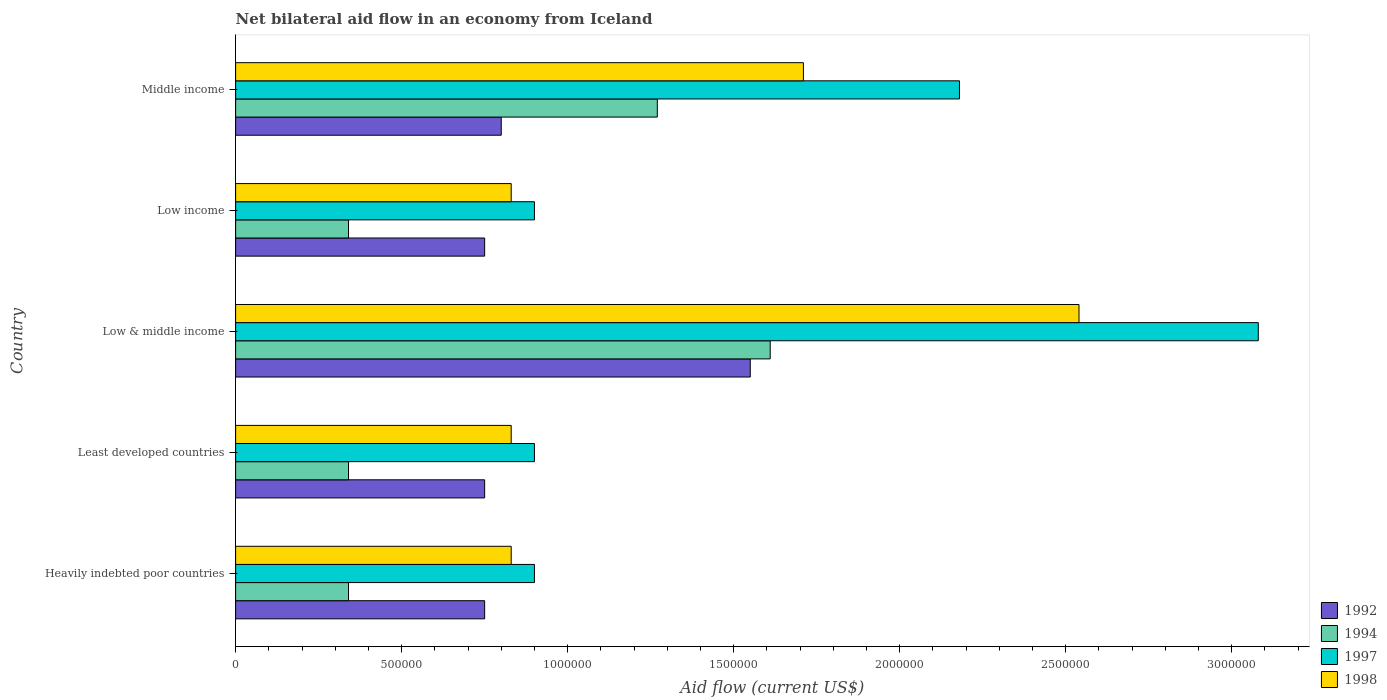How many bars are there on the 2nd tick from the bottom?
Your answer should be compact. 4. What is the label of the 5th group of bars from the top?
Ensure brevity in your answer.  Heavily indebted poor countries. In how many cases, is the number of bars for a given country not equal to the number of legend labels?
Keep it short and to the point. 0. What is the net bilateral aid flow in 1994 in Middle income?
Offer a terse response. 1.27e+06. Across all countries, what is the maximum net bilateral aid flow in 1998?
Offer a very short reply. 2.54e+06. In which country was the net bilateral aid flow in 1994 maximum?
Provide a succinct answer. Low & middle income. In which country was the net bilateral aid flow in 1992 minimum?
Your answer should be very brief. Heavily indebted poor countries. What is the total net bilateral aid flow in 1994 in the graph?
Offer a very short reply. 3.90e+06. What is the difference between the net bilateral aid flow in 1997 in Heavily indebted poor countries and the net bilateral aid flow in 1998 in Middle income?
Make the answer very short. -8.10e+05. What is the average net bilateral aid flow in 1997 per country?
Your answer should be compact. 1.59e+06. What is the difference between the net bilateral aid flow in 1998 and net bilateral aid flow in 1992 in Middle income?
Your answer should be very brief. 9.10e+05. In how many countries, is the net bilateral aid flow in 1992 greater than 2100000 US$?
Keep it short and to the point. 0. What is the ratio of the net bilateral aid flow in 1997 in Low & middle income to that in Low income?
Your response must be concise. 3.42. Is the net bilateral aid flow in 1997 in Least developed countries less than that in Middle income?
Ensure brevity in your answer.  Yes. Is the difference between the net bilateral aid flow in 1998 in Heavily indebted poor countries and Least developed countries greater than the difference between the net bilateral aid flow in 1992 in Heavily indebted poor countries and Least developed countries?
Offer a terse response. No. What is the difference between the highest and the second highest net bilateral aid flow in 1994?
Make the answer very short. 3.40e+05. What is the difference between the highest and the lowest net bilateral aid flow in 1997?
Give a very brief answer. 2.18e+06. Is the sum of the net bilateral aid flow in 1998 in Heavily indebted poor countries and Low & middle income greater than the maximum net bilateral aid flow in 1992 across all countries?
Keep it short and to the point. Yes. Is it the case that in every country, the sum of the net bilateral aid flow in 1992 and net bilateral aid flow in 1998 is greater than the sum of net bilateral aid flow in 1994 and net bilateral aid flow in 1997?
Your response must be concise. Yes. What does the 4th bar from the top in Least developed countries represents?
Give a very brief answer. 1992. What does the 2nd bar from the bottom in Low & middle income represents?
Give a very brief answer. 1994. Is it the case that in every country, the sum of the net bilateral aid flow in 1994 and net bilateral aid flow in 1998 is greater than the net bilateral aid flow in 1992?
Provide a short and direct response. Yes. How many bars are there?
Provide a succinct answer. 20. How many countries are there in the graph?
Make the answer very short. 5. Are the values on the major ticks of X-axis written in scientific E-notation?
Offer a terse response. No. Where does the legend appear in the graph?
Ensure brevity in your answer.  Bottom right. What is the title of the graph?
Make the answer very short. Net bilateral aid flow in an economy from Iceland. Does "1960" appear as one of the legend labels in the graph?
Offer a terse response. No. What is the label or title of the X-axis?
Provide a succinct answer. Aid flow (current US$). What is the label or title of the Y-axis?
Your answer should be very brief. Country. What is the Aid flow (current US$) in 1992 in Heavily indebted poor countries?
Make the answer very short. 7.50e+05. What is the Aid flow (current US$) of 1998 in Heavily indebted poor countries?
Your answer should be compact. 8.30e+05. What is the Aid flow (current US$) of 1992 in Least developed countries?
Give a very brief answer. 7.50e+05. What is the Aid flow (current US$) in 1994 in Least developed countries?
Your response must be concise. 3.40e+05. What is the Aid flow (current US$) of 1998 in Least developed countries?
Offer a very short reply. 8.30e+05. What is the Aid flow (current US$) in 1992 in Low & middle income?
Offer a terse response. 1.55e+06. What is the Aid flow (current US$) of 1994 in Low & middle income?
Provide a succinct answer. 1.61e+06. What is the Aid flow (current US$) of 1997 in Low & middle income?
Ensure brevity in your answer.  3.08e+06. What is the Aid flow (current US$) of 1998 in Low & middle income?
Offer a terse response. 2.54e+06. What is the Aid flow (current US$) in 1992 in Low income?
Provide a succinct answer. 7.50e+05. What is the Aid flow (current US$) in 1998 in Low income?
Make the answer very short. 8.30e+05. What is the Aid flow (current US$) of 1992 in Middle income?
Your answer should be compact. 8.00e+05. What is the Aid flow (current US$) of 1994 in Middle income?
Make the answer very short. 1.27e+06. What is the Aid flow (current US$) in 1997 in Middle income?
Provide a short and direct response. 2.18e+06. What is the Aid flow (current US$) of 1998 in Middle income?
Provide a succinct answer. 1.71e+06. Across all countries, what is the maximum Aid flow (current US$) in 1992?
Provide a succinct answer. 1.55e+06. Across all countries, what is the maximum Aid flow (current US$) in 1994?
Your response must be concise. 1.61e+06. Across all countries, what is the maximum Aid flow (current US$) in 1997?
Ensure brevity in your answer.  3.08e+06. Across all countries, what is the maximum Aid flow (current US$) of 1998?
Provide a succinct answer. 2.54e+06. Across all countries, what is the minimum Aid flow (current US$) in 1992?
Your answer should be compact. 7.50e+05. Across all countries, what is the minimum Aid flow (current US$) in 1994?
Give a very brief answer. 3.40e+05. Across all countries, what is the minimum Aid flow (current US$) in 1997?
Give a very brief answer. 9.00e+05. Across all countries, what is the minimum Aid flow (current US$) of 1998?
Ensure brevity in your answer.  8.30e+05. What is the total Aid flow (current US$) of 1992 in the graph?
Offer a very short reply. 4.60e+06. What is the total Aid flow (current US$) of 1994 in the graph?
Your answer should be very brief. 3.90e+06. What is the total Aid flow (current US$) in 1997 in the graph?
Your answer should be compact. 7.96e+06. What is the total Aid flow (current US$) in 1998 in the graph?
Your answer should be compact. 6.74e+06. What is the difference between the Aid flow (current US$) of 1992 in Heavily indebted poor countries and that in Least developed countries?
Provide a succinct answer. 0. What is the difference between the Aid flow (current US$) of 1994 in Heavily indebted poor countries and that in Least developed countries?
Your response must be concise. 0. What is the difference between the Aid flow (current US$) of 1992 in Heavily indebted poor countries and that in Low & middle income?
Provide a succinct answer. -8.00e+05. What is the difference between the Aid flow (current US$) in 1994 in Heavily indebted poor countries and that in Low & middle income?
Offer a very short reply. -1.27e+06. What is the difference between the Aid flow (current US$) in 1997 in Heavily indebted poor countries and that in Low & middle income?
Your response must be concise. -2.18e+06. What is the difference between the Aid flow (current US$) in 1998 in Heavily indebted poor countries and that in Low & middle income?
Your answer should be very brief. -1.71e+06. What is the difference between the Aid flow (current US$) in 1992 in Heavily indebted poor countries and that in Low income?
Your answer should be very brief. 0. What is the difference between the Aid flow (current US$) in 1997 in Heavily indebted poor countries and that in Low income?
Your answer should be compact. 0. What is the difference between the Aid flow (current US$) of 1998 in Heavily indebted poor countries and that in Low income?
Provide a short and direct response. 0. What is the difference between the Aid flow (current US$) in 1994 in Heavily indebted poor countries and that in Middle income?
Offer a terse response. -9.30e+05. What is the difference between the Aid flow (current US$) in 1997 in Heavily indebted poor countries and that in Middle income?
Offer a terse response. -1.28e+06. What is the difference between the Aid flow (current US$) of 1998 in Heavily indebted poor countries and that in Middle income?
Offer a very short reply. -8.80e+05. What is the difference between the Aid flow (current US$) in 1992 in Least developed countries and that in Low & middle income?
Provide a short and direct response. -8.00e+05. What is the difference between the Aid flow (current US$) in 1994 in Least developed countries and that in Low & middle income?
Offer a very short reply. -1.27e+06. What is the difference between the Aid flow (current US$) of 1997 in Least developed countries and that in Low & middle income?
Your answer should be very brief. -2.18e+06. What is the difference between the Aid flow (current US$) of 1998 in Least developed countries and that in Low & middle income?
Ensure brevity in your answer.  -1.71e+06. What is the difference between the Aid flow (current US$) in 1998 in Least developed countries and that in Low income?
Ensure brevity in your answer.  0. What is the difference between the Aid flow (current US$) of 1992 in Least developed countries and that in Middle income?
Offer a terse response. -5.00e+04. What is the difference between the Aid flow (current US$) in 1994 in Least developed countries and that in Middle income?
Provide a short and direct response. -9.30e+05. What is the difference between the Aid flow (current US$) of 1997 in Least developed countries and that in Middle income?
Keep it short and to the point. -1.28e+06. What is the difference between the Aid flow (current US$) in 1998 in Least developed countries and that in Middle income?
Your answer should be very brief. -8.80e+05. What is the difference between the Aid flow (current US$) of 1994 in Low & middle income and that in Low income?
Provide a short and direct response. 1.27e+06. What is the difference between the Aid flow (current US$) in 1997 in Low & middle income and that in Low income?
Give a very brief answer. 2.18e+06. What is the difference between the Aid flow (current US$) of 1998 in Low & middle income and that in Low income?
Provide a short and direct response. 1.71e+06. What is the difference between the Aid flow (current US$) in 1992 in Low & middle income and that in Middle income?
Offer a very short reply. 7.50e+05. What is the difference between the Aid flow (current US$) in 1994 in Low & middle income and that in Middle income?
Make the answer very short. 3.40e+05. What is the difference between the Aid flow (current US$) of 1998 in Low & middle income and that in Middle income?
Your answer should be very brief. 8.30e+05. What is the difference between the Aid flow (current US$) in 1994 in Low income and that in Middle income?
Provide a short and direct response. -9.30e+05. What is the difference between the Aid flow (current US$) in 1997 in Low income and that in Middle income?
Give a very brief answer. -1.28e+06. What is the difference between the Aid flow (current US$) of 1998 in Low income and that in Middle income?
Your response must be concise. -8.80e+05. What is the difference between the Aid flow (current US$) in 1994 in Heavily indebted poor countries and the Aid flow (current US$) in 1997 in Least developed countries?
Provide a succinct answer. -5.60e+05. What is the difference between the Aid flow (current US$) in 1994 in Heavily indebted poor countries and the Aid flow (current US$) in 1998 in Least developed countries?
Make the answer very short. -4.90e+05. What is the difference between the Aid flow (current US$) of 1997 in Heavily indebted poor countries and the Aid flow (current US$) of 1998 in Least developed countries?
Your response must be concise. 7.00e+04. What is the difference between the Aid flow (current US$) in 1992 in Heavily indebted poor countries and the Aid flow (current US$) in 1994 in Low & middle income?
Provide a short and direct response. -8.60e+05. What is the difference between the Aid flow (current US$) of 1992 in Heavily indebted poor countries and the Aid flow (current US$) of 1997 in Low & middle income?
Your answer should be very brief. -2.33e+06. What is the difference between the Aid flow (current US$) of 1992 in Heavily indebted poor countries and the Aid flow (current US$) of 1998 in Low & middle income?
Offer a very short reply. -1.79e+06. What is the difference between the Aid flow (current US$) of 1994 in Heavily indebted poor countries and the Aid flow (current US$) of 1997 in Low & middle income?
Ensure brevity in your answer.  -2.74e+06. What is the difference between the Aid flow (current US$) of 1994 in Heavily indebted poor countries and the Aid flow (current US$) of 1998 in Low & middle income?
Provide a succinct answer. -2.20e+06. What is the difference between the Aid flow (current US$) in 1997 in Heavily indebted poor countries and the Aid flow (current US$) in 1998 in Low & middle income?
Your answer should be very brief. -1.64e+06. What is the difference between the Aid flow (current US$) of 1992 in Heavily indebted poor countries and the Aid flow (current US$) of 1997 in Low income?
Keep it short and to the point. -1.50e+05. What is the difference between the Aid flow (current US$) in 1992 in Heavily indebted poor countries and the Aid flow (current US$) in 1998 in Low income?
Provide a short and direct response. -8.00e+04. What is the difference between the Aid flow (current US$) in 1994 in Heavily indebted poor countries and the Aid flow (current US$) in 1997 in Low income?
Provide a short and direct response. -5.60e+05. What is the difference between the Aid flow (current US$) in 1994 in Heavily indebted poor countries and the Aid flow (current US$) in 1998 in Low income?
Make the answer very short. -4.90e+05. What is the difference between the Aid flow (current US$) of 1992 in Heavily indebted poor countries and the Aid flow (current US$) of 1994 in Middle income?
Give a very brief answer. -5.20e+05. What is the difference between the Aid flow (current US$) in 1992 in Heavily indebted poor countries and the Aid flow (current US$) in 1997 in Middle income?
Your answer should be compact. -1.43e+06. What is the difference between the Aid flow (current US$) in 1992 in Heavily indebted poor countries and the Aid flow (current US$) in 1998 in Middle income?
Your answer should be very brief. -9.60e+05. What is the difference between the Aid flow (current US$) of 1994 in Heavily indebted poor countries and the Aid flow (current US$) of 1997 in Middle income?
Your response must be concise. -1.84e+06. What is the difference between the Aid flow (current US$) of 1994 in Heavily indebted poor countries and the Aid flow (current US$) of 1998 in Middle income?
Your answer should be very brief. -1.37e+06. What is the difference between the Aid flow (current US$) of 1997 in Heavily indebted poor countries and the Aid flow (current US$) of 1998 in Middle income?
Your answer should be very brief. -8.10e+05. What is the difference between the Aid flow (current US$) of 1992 in Least developed countries and the Aid flow (current US$) of 1994 in Low & middle income?
Provide a short and direct response. -8.60e+05. What is the difference between the Aid flow (current US$) of 1992 in Least developed countries and the Aid flow (current US$) of 1997 in Low & middle income?
Make the answer very short. -2.33e+06. What is the difference between the Aid flow (current US$) in 1992 in Least developed countries and the Aid flow (current US$) in 1998 in Low & middle income?
Make the answer very short. -1.79e+06. What is the difference between the Aid flow (current US$) in 1994 in Least developed countries and the Aid flow (current US$) in 1997 in Low & middle income?
Provide a short and direct response. -2.74e+06. What is the difference between the Aid flow (current US$) in 1994 in Least developed countries and the Aid flow (current US$) in 1998 in Low & middle income?
Ensure brevity in your answer.  -2.20e+06. What is the difference between the Aid flow (current US$) in 1997 in Least developed countries and the Aid flow (current US$) in 1998 in Low & middle income?
Make the answer very short. -1.64e+06. What is the difference between the Aid flow (current US$) of 1992 in Least developed countries and the Aid flow (current US$) of 1997 in Low income?
Your response must be concise. -1.50e+05. What is the difference between the Aid flow (current US$) of 1992 in Least developed countries and the Aid flow (current US$) of 1998 in Low income?
Ensure brevity in your answer.  -8.00e+04. What is the difference between the Aid flow (current US$) in 1994 in Least developed countries and the Aid flow (current US$) in 1997 in Low income?
Your answer should be very brief. -5.60e+05. What is the difference between the Aid flow (current US$) of 1994 in Least developed countries and the Aid flow (current US$) of 1998 in Low income?
Ensure brevity in your answer.  -4.90e+05. What is the difference between the Aid flow (current US$) of 1992 in Least developed countries and the Aid flow (current US$) of 1994 in Middle income?
Ensure brevity in your answer.  -5.20e+05. What is the difference between the Aid flow (current US$) in 1992 in Least developed countries and the Aid flow (current US$) in 1997 in Middle income?
Your response must be concise. -1.43e+06. What is the difference between the Aid flow (current US$) of 1992 in Least developed countries and the Aid flow (current US$) of 1998 in Middle income?
Provide a short and direct response. -9.60e+05. What is the difference between the Aid flow (current US$) of 1994 in Least developed countries and the Aid flow (current US$) of 1997 in Middle income?
Give a very brief answer. -1.84e+06. What is the difference between the Aid flow (current US$) of 1994 in Least developed countries and the Aid flow (current US$) of 1998 in Middle income?
Your answer should be very brief. -1.37e+06. What is the difference between the Aid flow (current US$) of 1997 in Least developed countries and the Aid flow (current US$) of 1998 in Middle income?
Your answer should be very brief. -8.10e+05. What is the difference between the Aid flow (current US$) in 1992 in Low & middle income and the Aid flow (current US$) in 1994 in Low income?
Keep it short and to the point. 1.21e+06. What is the difference between the Aid flow (current US$) in 1992 in Low & middle income and the Aid flow (current US$) in 1997 in Low income?
Keep it short and to the point. 6.50e+05. What is the difference between the Aid flow (current US$) in 1992 in Low & middle income and the Aid flow (current US$) in 1998 in Low income?
Make the answer very short. 7.20e+05. What is the difference between the Aid flow (current US$) in 1994 in Low & middle income and the Aid flow (current US$) in 1997 in Low income?
Your response must be concise. 7.10e+05. What is the difference between the Aid flow (current US$) in 1994 in Low & middle income and the Aid flow (current US$) in 1998 in Low income?
Ensure brevity in your answer.  7.80e+05. What is the difference between the Aid flow (current US$) in 1997 in Low & middle income and the Aid flow (current US$) in 1998 in Low income?
Your response must be concise. 2.25e+06. What is the difference between the Aid flow (current US$) in 1992 in Low & middle income and the Aid flow (current US$) in 1997 in Middle income?
Your answer should be compact. -6.30e+05. What is the difference between the Aid flow (current US$) in 1994 in Low & middle income and the Aid flow (current US$) in 1997 in Middle income?
Your answer should be very brief. -5.70e+05. What is the difference between the Aid flow (current US$) of 1997 in Low & middle income and the Aid flow (current US$) of 1998 in Middle income?
Provide a succinct answer. 1.37e+06. What is the difference between the Aid flow (current US$) in 1992 in Low income and the Aid flow (current US$) in 1994 in Middle income?
Your answer should be very brief. -5.20e+05. What is the difference between the Aid flow (current US$) of 1992 in Low income and the Aid flow (current US$) of 1997 in Middle income?
Ensure brevity in your answer.  -1.43e+06. What is the difference between the Aid flow (current US$) in 1992 in Low income and the Aid flow (current US$) in 1998 in Middle income?
Offer a very short reply. -9.60e+05. What is the difference between the Aid flow (current US$) of 1994 in Low income and the Aid flow (current US$) of 1997 in Middle income?
Offer a very short reply. -1.84e+06. What is the difference between the Aid flow (current US$) in 1994 in Low income and the Aid flow (current US$) in 1998 in Middle income?
Give a very brief answer. -1.37e+06. What is the difference between the Aid flow (current US$) in 1997 in Low income and the Aid flow (current US$) in 1998 in Middle income?
Offer a terse response. -8.10e+05. What is the average Aid flow (current US$) of 1992 per country?
Your response must be concise. 9.20e+05. What is the average Aid flow (current US$) in 1994 per country?
Your response must be concise. 7.80e+05. What is the average Aid flow (current US$) in 1997 per country?
Give a very brief answer. 1.59e+06. What is the average Aid flow (current US$) of 1998 per country?
Offer a very short reply. 1.35e+06. What is the difference between the Aid flow (current US$) of 1992 and Aid flow (current US$) of 1997 in Heavily indebted poor countries?
Your response must be concise. -1.50e+05. What is the difference between the Aid flow (current US$) of 1992 and Aid flow (current US$) of 1998 in Heavily indebted poor countries?
Offer a terse response. -8.00e+04. What is the difference between the Aid flow (current US$) in 1994 and Aid flow (current US$) in 1997 in Heavily indebted poor countries?
Your answer should be very brief. -5.60e+05. What is the difference between the Aid flow (current US$) in 1994 and Aid flow (current US$) in 1998 in Heavily indebted poor countries?
Provide a short and direct response. -4.90e+05. What is the difference between the Aid flow (current US$) in 1992 and Aid flow (current US$) in 1997 in Least developed countries?
Your response must be concise. -1.50e+05. What is the difference between the Aid flow (current US$) of 1994 and Aid flow (current US$) of 1997 in Least developed countries?
Provide a short and direct response. -5.60e+05. What is the difference between the Aid flow (current US$) of 1994 and Aid flow (current US$) of 1998 in Least developed countries?
Your response must be concise. -4.90e+05. What is the difference between the Aid flow (current US$) of 1992 and Aid flow (current US$) of 1994 in Low & middle income?
Offer a terse response. -6.00e+04. What is the difference between the Aid flow (current US$) of 1992 and Aid flow (current US$) of 1997 in Low & middle income?
Keep it short and to the point. -1.53e+06. What is the difference between the Aid flow (current US$) in 1992 and Aid flow (current US$) in 1998 in Low & middle income?
Offer a terse response. -9.90e+05. What is the difference between the Aid flow (current US$) in 1994 and Aid flow (current US$) in 1997 in Low & middle income?
Offer a very short reply. -1.47e+06. What is the difference between the Aid flow (current US$) of 1994 and Aid flow (current US$) of 1998 in Low & middle income?
Give a very brief answer. -9.30e+05. What is the difference between the Aid flow (current US$) of 1997 and Aid flow (current US$) of 1998 in Low & middle income?
Ensure brevity in your answer.  5.40e+05. What is the difference between the Aid flow (current US$) in 1994 and Aid flow (current US$) in 1997 in Low income?
Make the answer very short. -5.60e+05. What is the difference between the Aid flow (current US$) in 1994 and Aid flow (current US$) in 1998 in Low income?
Give a very brief answer. -4.90e+05. What is the difference between the Aid flow (current US$) of 1997 and Aid flow (current US$) of 1998 in Low income?
Provide a succinct answer. 7.00e+04. What is the difference between the Aid flow (current US$) of 1992 and Aid flow (current US$) of 1994 in Middle income?
Keep it short and to the point. -4.70e+05. What is the difference between the Aid flow (current US$) in 1992 and Aid flow (current US$) in 1997 in Middle income?
Offer a terse response. -1.38e+06. What is the difference between the Aid flow (current US$) in 1992 and Aid flow (current US$) in 1998 in Middle income?
Your response must be concise. -9.10e+05. What is the difference between the Aid flow (current US$) of 1994 and Aid flow (current US$) of 1997 in Middle income?
Give a very brief answer. -9.10e+05. What is the difference between the Aid flow (current US$) in 1994 and Aid flow (current US$) in 1998 in Middle income?
Offer a terse response. -4.40e+05. What is the difference between the Aid flow (current US$) in 1997 and Aid flow (current US$) in 1998 in Middle income?
Provide a succinct answer. 4.70e+05. What is the ratio of the Aid flow (current US$) in 1992 in Heavily indebted poor countries to that in Low & middle income?
Offer a very short reply. 0.48. What is the ratio of the Aid flow (current US$) in 1994 in Heavily indebted poor countries to that in Low & middle income?
Offer a very short reply. 0.21. What is the ratio of the Aid flow (current US$) in 1997 in Heavily indebted poor countries to that in Low & middle income?
Make the answer very short. 0.29. What is the ratio of the Aid flow (current US$) of 1998 in Heavily indebted poor countries to that in Low & middle income?
Make the answer very short. 0.33. What is the ratio of the Aid flow (current US$) of 1992 in Heavily indebted poor countries to that in Low income?
Provide a short and direct response. 1. What is the ratio of the Aid flow (current US$) of 1997 in Heavily indebted poor countries to that in Low income?
Offer a very short reply. 1. What is the ratio of the Aid flow (current US$) in 1998 in Heavily indebted poor countries to that in Low income?
Give a very brief answer. 1. What is the ratio of the Aid flow (current US$) of 1992 in Heavily indebted poor countries to that in Middle income?
Your response must be concise. 0.94. What is the ratio of the Aid flow (current US$) in 1994 in Heavily indebted poor countries to that in Middle income?
Provide a succinct answer. 0.27. What is the ratio of the Aid flow (current US$) of 1997 in Heavily indebted poor countries to that in Middle income?
Your answer should be very brief. 0.41. What is the ratio of the Aid flow (current US$) of 1998 in Heavily indebted poor countries to that in Middle income?
Offer a very short reply. 0.49. What is the ratio of the Aid flow (current US$) in 1992 in Least developed countries to that in Low & middle income?
Give a very brief answer. 0.48. What is the ratio of the Aid flow (current US$) in 1994 in Least developed countries to that in Low & middle income?
Your answer should be very brief. 0.21. What is the ratio of the Aid flow (current US$) of 1997 in Least developed countries to that in Low & middle income?
Keep it short and to the point. 0.29. What is the ratio of the Aid flow (current US$) of 1998 in Least developed countries to that in Low & middle income?
Give a very brief answer. 0.33. What is the ratio of the Aid flow (current US$) in 1992 in Least developed countries to that in Low income?
Provide a short and direct response. 1. What is the ratio of the Aid flow (current US$) in 1997 in Least developed countries to that in Low income?
Give a very brief answer. 1. What is the ratio of the Aid flow (current US$) of 1998 in Least developed countries to that in Low income?
Provide a short and direct response. 1. What is the ratio of the Aid flow (current US$) of 1994 in Least developed countries to that in Middle income?
Your response must be concise. 0.27. What is the ratio of the Aid flow (current US$) of 1997 in Least developed countries to that in Middle income?
Provide a short and direct response. 0.41. What is the ratio of the Aid flow (current US$) of 1998 in Least developed countries to that in Middle income?
Your response must be concise. 0.49. What is the ratio of the Aid flow (current US$) of 1992 in Low & middle income to that in Low income?
Give a very brief answer. 2.07. What is the ratio of the Aid flow (current US$) of 1994 in Low & middle income to that in Low income?
Keep it short and to the point. 4.74. What is the ratio of the Aid flow (current US$) in 1997 in Low & middle income to that in Low income?
Offer a very short reply. 3.42. What is the ratio of the Aid flow (current US$) of 1998 in Low & middle income to that in Low income?
Your response must be concise. 3.06. What is the ratio of the Aid flow (current US$) of 1992 in Low & middle income to that in Middle income?
Provide a succinct answer. 1.94. What is the ratio of the Aid flow (current US$) in 1994 in Low & middle income to that in Middle income?
Your answer should be compact. 1.27. What is the ratio of the Aid flow (current US$) of 1997 in Low & middle income to that in Middle income?
Offer a very short reply. 1.41. What is the ratio of the Aid flow (current US$) of 1998 in Low & middle income to that in Middle income?
Provide a short and direct response. 1.49. What is the ratio of the Aid flow (current US$) of 1994 in Low income to that in Middle income?
Provide a short and direct response. 0.27. What is the ratio of the Aid flow (current US$) of 1997 in Low income to that in Middle income?
Your answer should be compact. 0.41. What is the ratio of the Aid flow (current US$) of 1998 in Low income to that in Middle income?
Your answer should be very brief. 0.49. What is the difference between the highest and the second highest Aid flow (current US$) of 1992?
Keep it short and to the point. 7.50e+05. What is the difference between the highest and the second highest Aid flow (current US$) of 1994?
Your response must be concise. 3.40e+05. What is the difference between the highest and the second highest Aid flow (current US$) of 1997?
Your answer should be compact. 9.00e+05. What is the difference between the highest and the second highest Aid flow (current US$) of 1998?
Your response must be concise. 8.30e+05. What is the difference between the highest and the lowest Aid flow (current US$) in 1994?
Provide a short and direct response. 1.27e+06. What is the difference between the highest and the lowest Aid flow (current US$) in 1997?
Make the answer very short. 2.18e+06. What is the difference between the highest and the lowest Aid flow (current US$) in 1998?
Make the answer very short. 1.71e+06. 